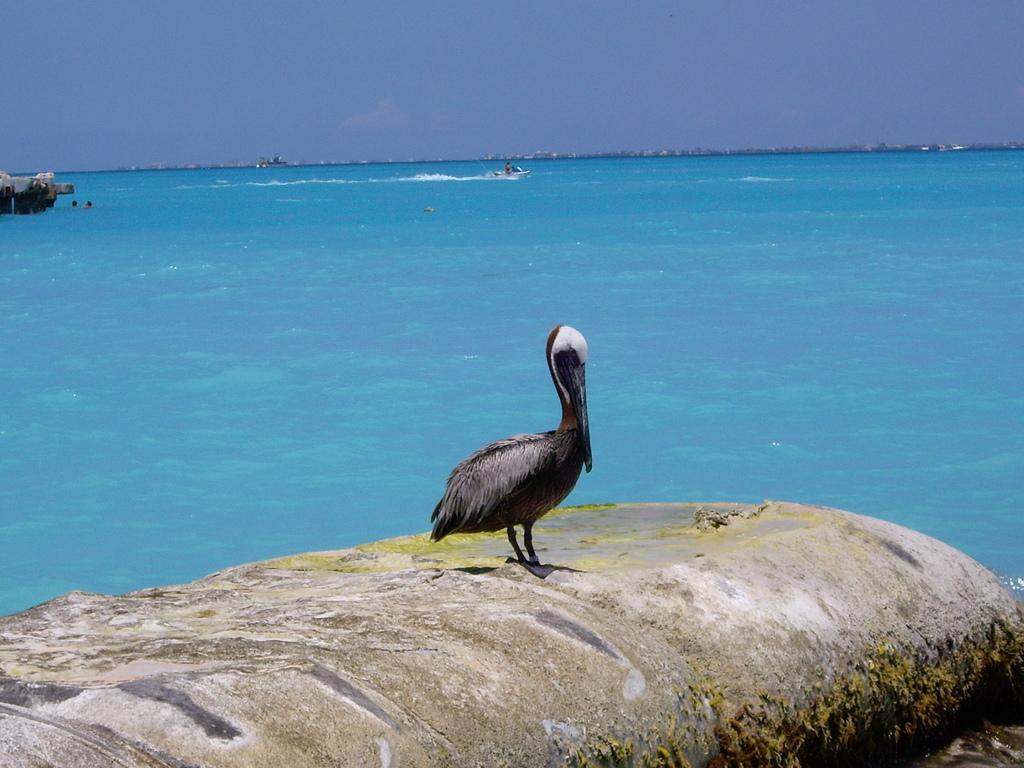Could you give a brief overview of what you see in this image? In the picture we can see brown pelican which is on the stone surface and in the background of the picture there is water and we can see some persons and there are some boats and top of the picture there is clear sky. 